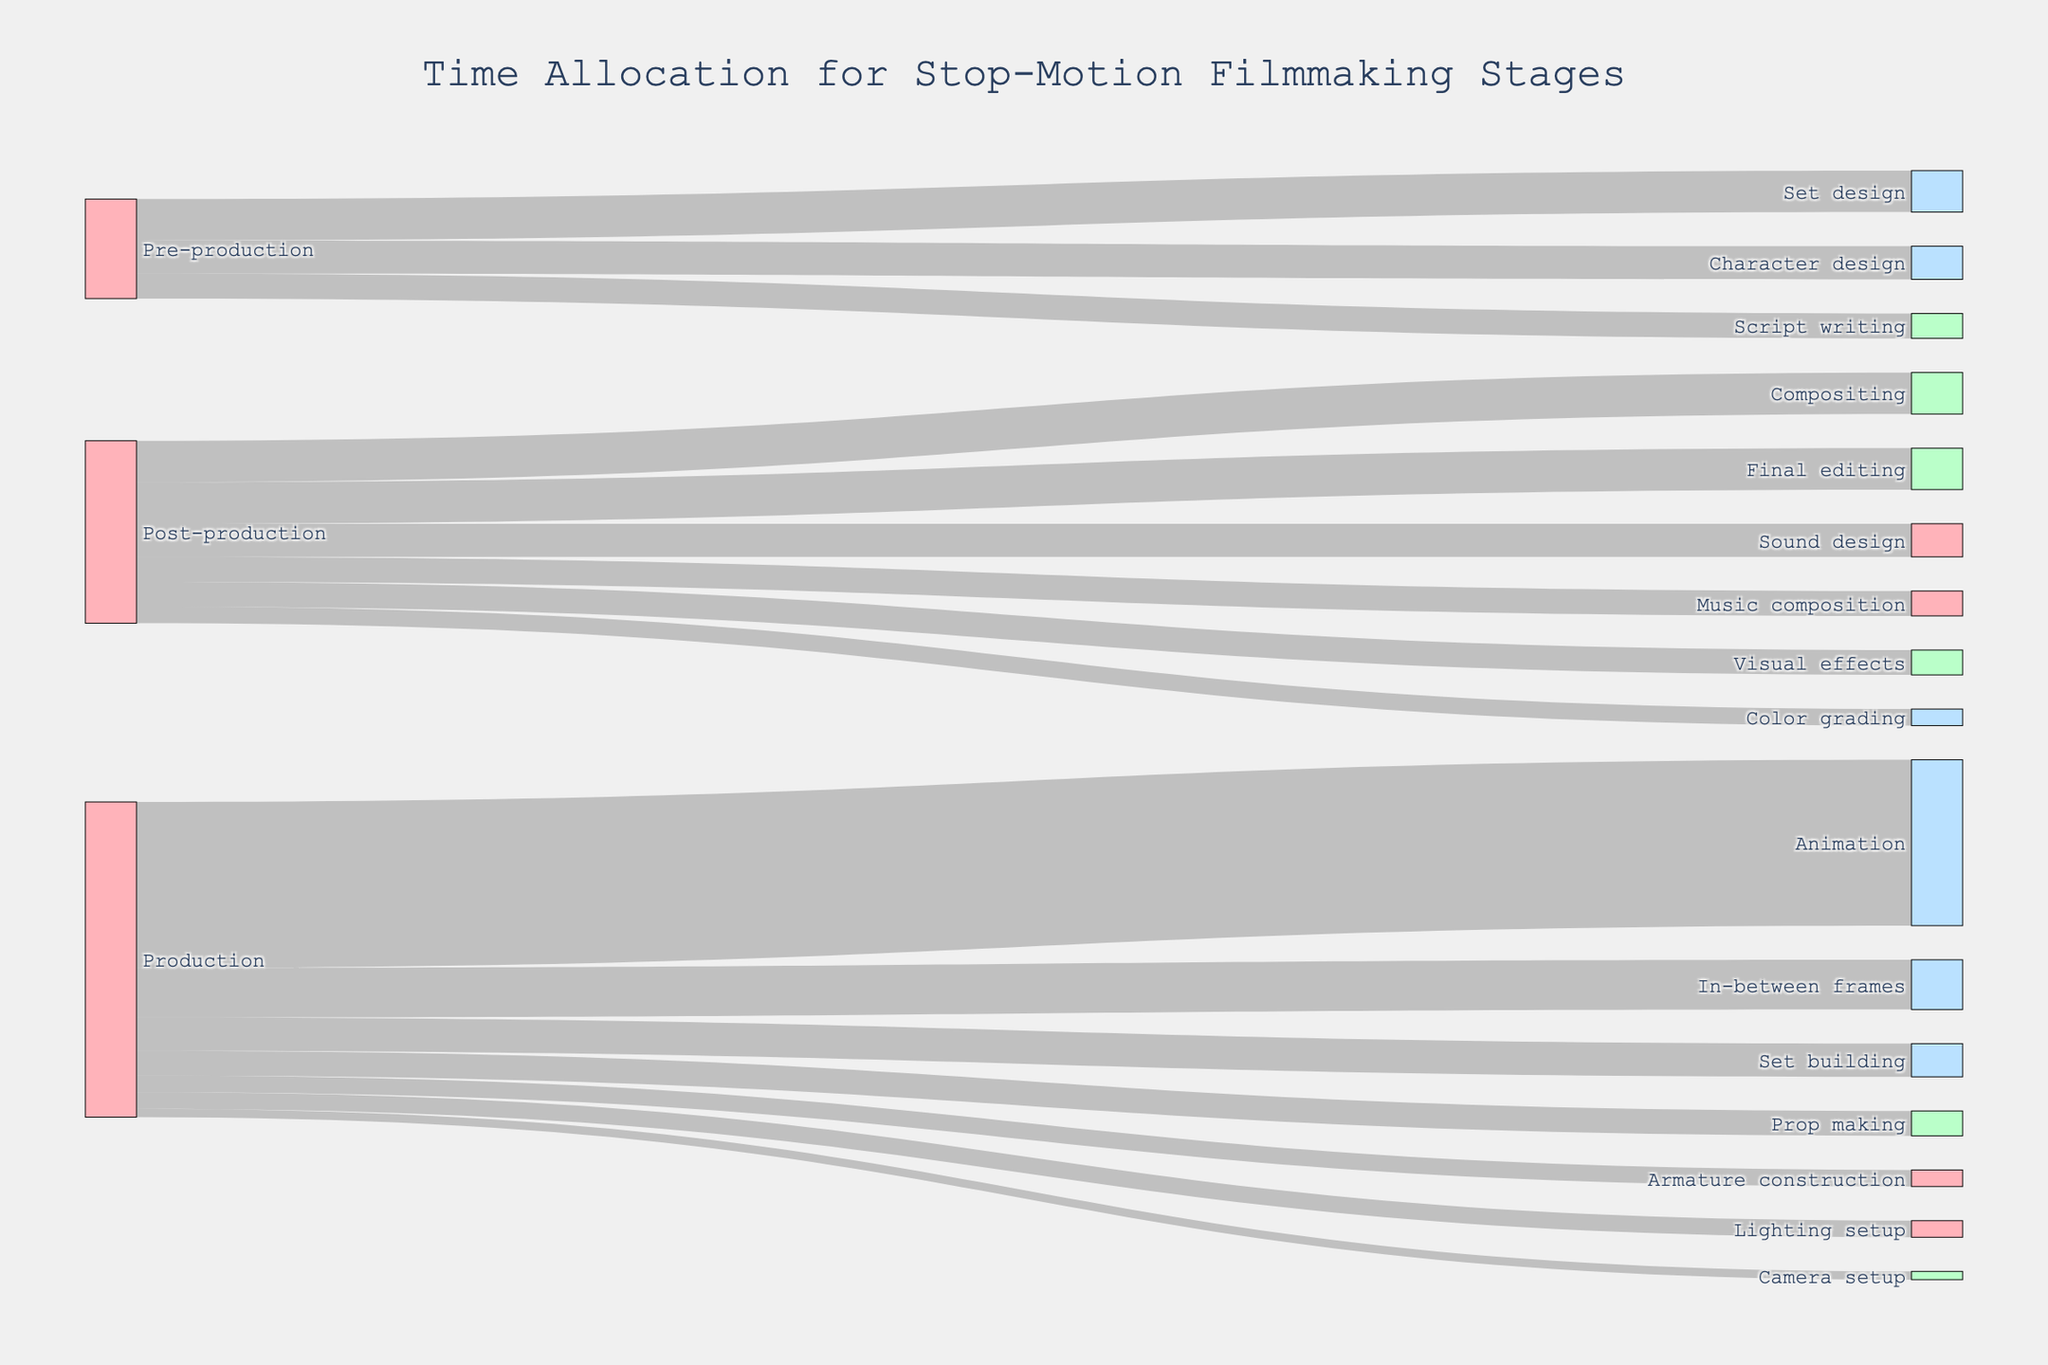What is the title of the Sankey diagram? The title is prominently displayed at the top of the figure. By reading it, one can identify the main topic of the diagram.
Answer: Time Allocation for Stop-Motion Filmmaking Stages Which activity in the Production stage takes the most time? Look at the labels under the Production stage and identify the one with the highest value linked to it.
Answer: Animation How much time is allocated to Set building in the Production stage? Find Set building under the Production stage and read its corresponding value.
Answer: 20 Compare the time spent on Visual effects and Music composition in the Post-production stage. Which one takes more time? Identify the values linked to Visual effects and Music composition from the Post-production stage and compare them.
Answer: Visual effects What's the total time allocated for Post-production activities? Sum the values of all Post-production activities (Compositing, Visual effects, Color grading, Sound design, Music composition, Final editing).
Answer: 110 Which stage has the highest single time allocation for any activity, and what is that activity? Look across all stages (Pre-production, Production, Post-production) and find the single activity with the highest value.
Answer: Production, Animation How does the time spent on Prop making compare to the time spent on Set design? Identify and compare the values linked to Prop making in the Production stage and Set design in the Pre-production stage.
Answer: Set design takes more time If you sum the time allocation for Lighting setup and Camera setup in the Production stage, what is the result? Add the values for Lighting setup (10) and Camera setup (5).
Answer: 15 What's the difference in time allocation between Final editing and Script writing? Subtract the value of Script writing from the value of Final editing.
Answer: 10 Is more time spent on Character design or Sound design? Compare the values assigned to Character design in Pre-production and Sound design in Post-production.
Answer: Character design 